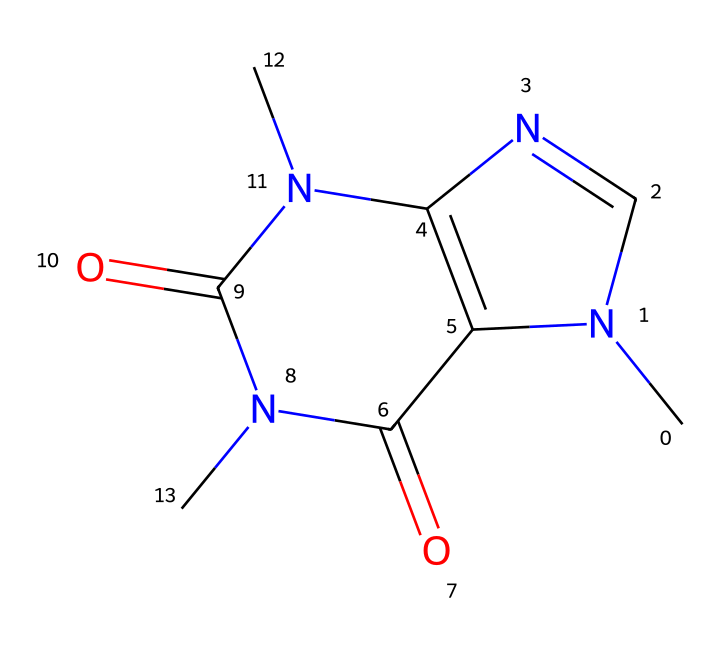What is the molecular formula of caffeine? To determine the molecular formula, you count the number of each type of atom in the provided SMILES representation. In the SMILES, there are 8 carbon (C) atoms, 10 hydrogen (H) atoms, 4 nitrogen (N) atoms, and 2 oxygen (O) atoms, leading to the formula C8H10N4O2.
Answer: C8H10N4O2 How many rings are present in the caffeine structure? By analyzing the SMILES representation, we look for the presence of connected cycles. The structure of caffeine contains two fused rings indicated by the "N1" and "C2", confirming that there are two rings.
Answer: 2 What type of functional groups are present in caffeine? Reviewing the structure, caffeine contains amine groups (indicated by nitrogen atoms) and carbonyl groups (indicated by the carbon-oxygen connections). The presence of these groups helps identify its unique functional properties.
Answer: amine and carbonyl Does caffeine contain a heterocyclic structure? Caffeine has a nitrogen atom in a ring, classifying it as heterocyclic, as it includes atoms other than carbon in its cyclic structure. This is significant in its chemical behavior and properties as a stimulant.
Answer: yes How many total atoms are in the caffeine molecule? To find the total number of atoms, sum the atoms from the molecular formula C8H10N4O2: 8 (C) + 10 (H) + 4 (N) + 2 (O) = 24 total atoms in caffeine.
Answer: 24 Is caffeine a natural or synthetic compound? Caffeine is primarily obtained from natural sources such as tea leaves, coffee beans, and cacao pods, although it can also be synthesized. Its predominant occurrence in nature highlights its classification as a natural compound.
Answer: natural 